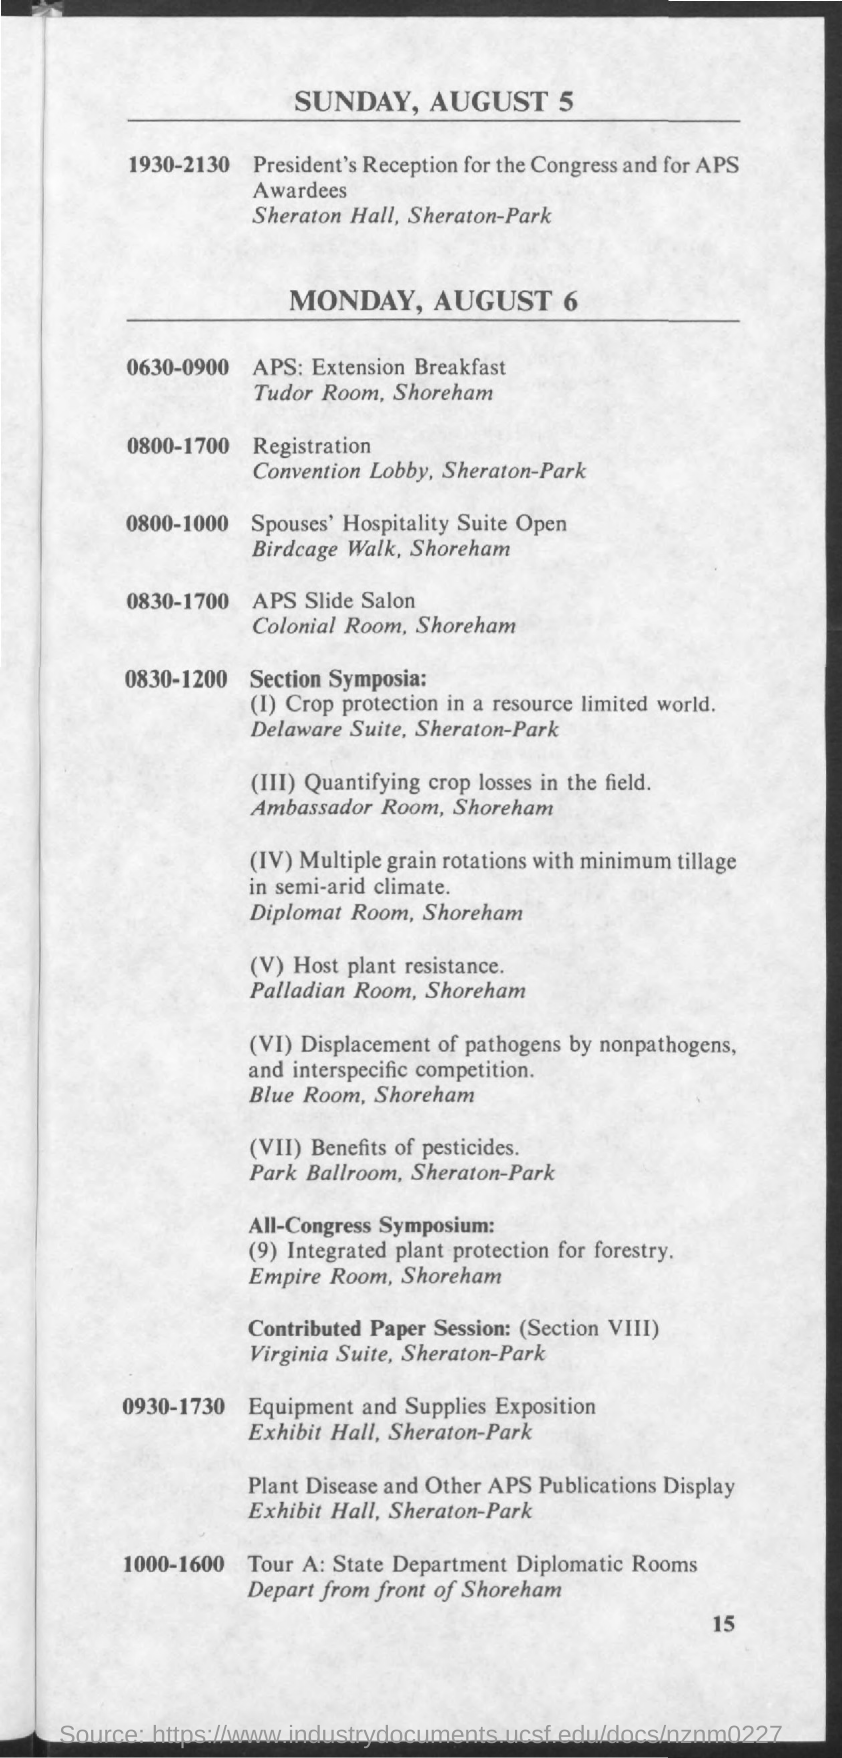What is the schedule at the time of 1930-2130 on sunday , august 5 ?
Give a very brief answer. President's reception for the congress and for aps awardees. What is the schedule at the time of 0800-1700 on monday, august 6 ?
Make the answer very short. Registration. 